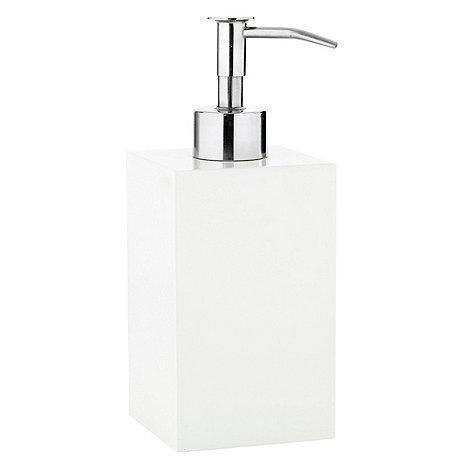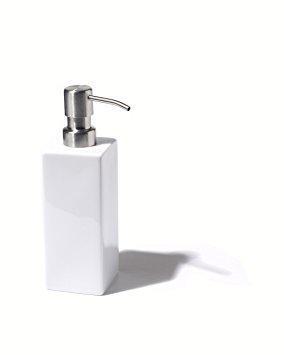The first image is the image on the left, the second image is the image on the right. Evaluate the accuracy of this statement regarding the images: "The nozzles of the dispensers in the left and right images face generally away from each other.". Is it true? Answer yes or no. No. The first image is the image on the left, the second image is the image on the right. Evaluate the accuracy of this statement regarding the images: "The rectangular dispenser on the left is taller than the white dispenser on the right.". Is it true? Answer yes or no. Yes. 